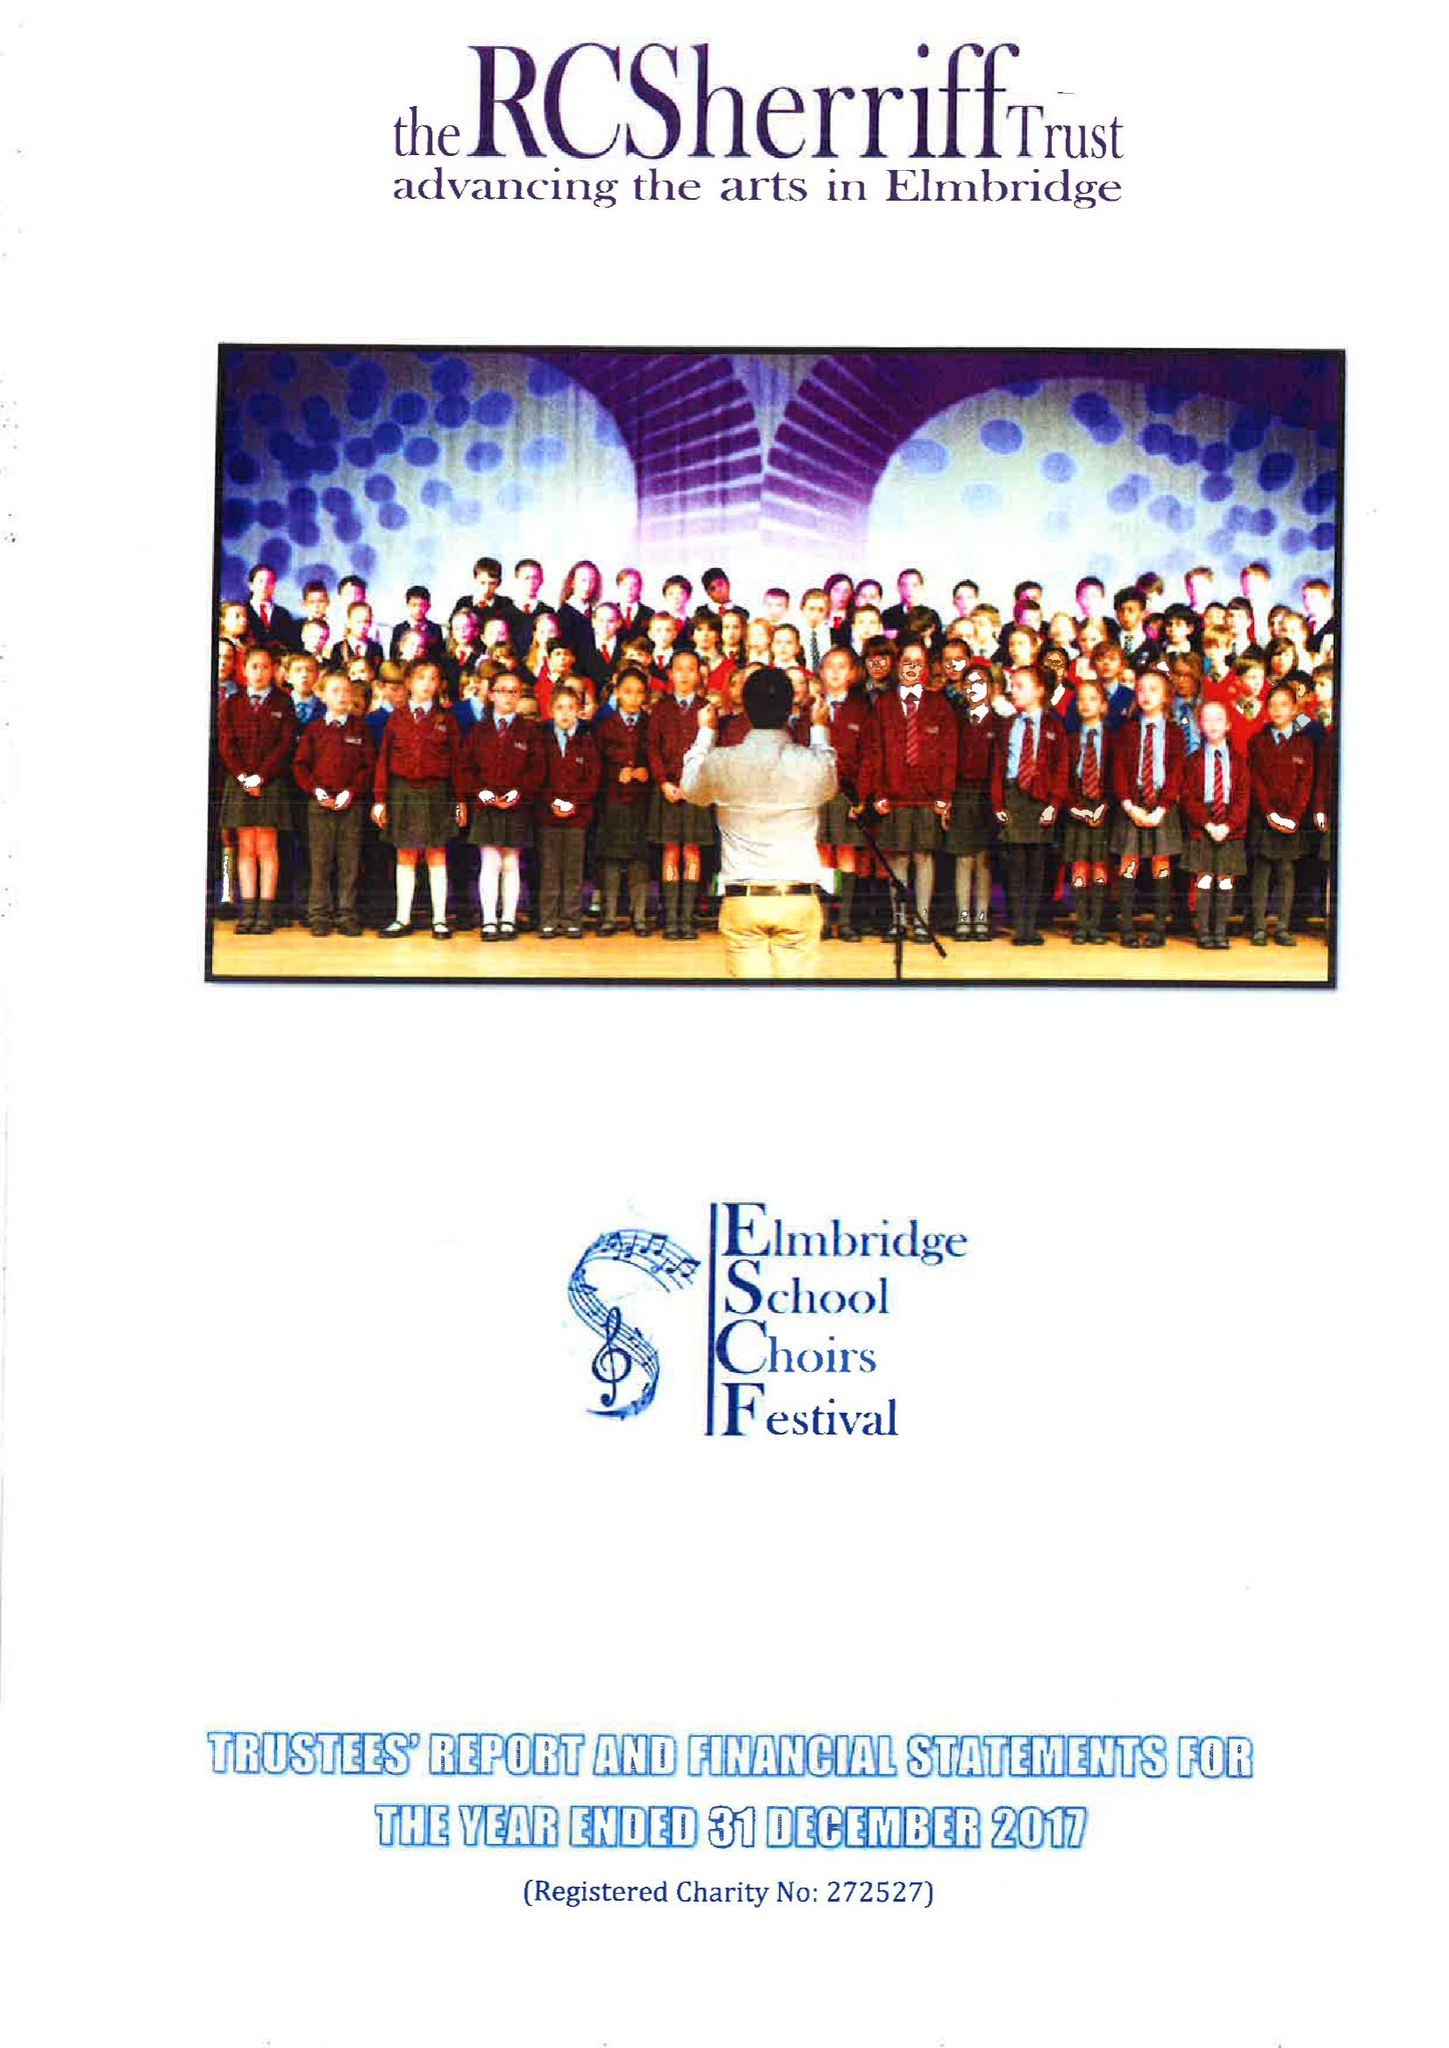What is the value for the income_annually_in_british_pounds?
Answer the question using a single word or phrase. 193541.00 